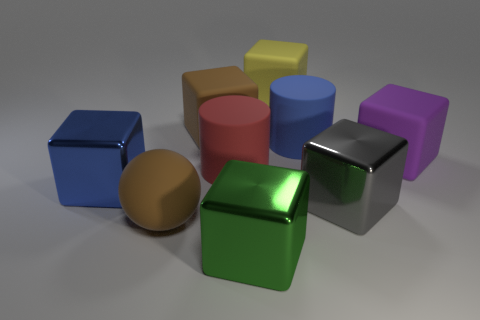Can you suggest a real-world application where these objects might be used? These geometric objects might be used in educational settings, such as a classroom for teaching geometry or spatial reasoning. They could also be part of a 3D modeling software tutorial, helping users learn about rendering and lighting effects. 